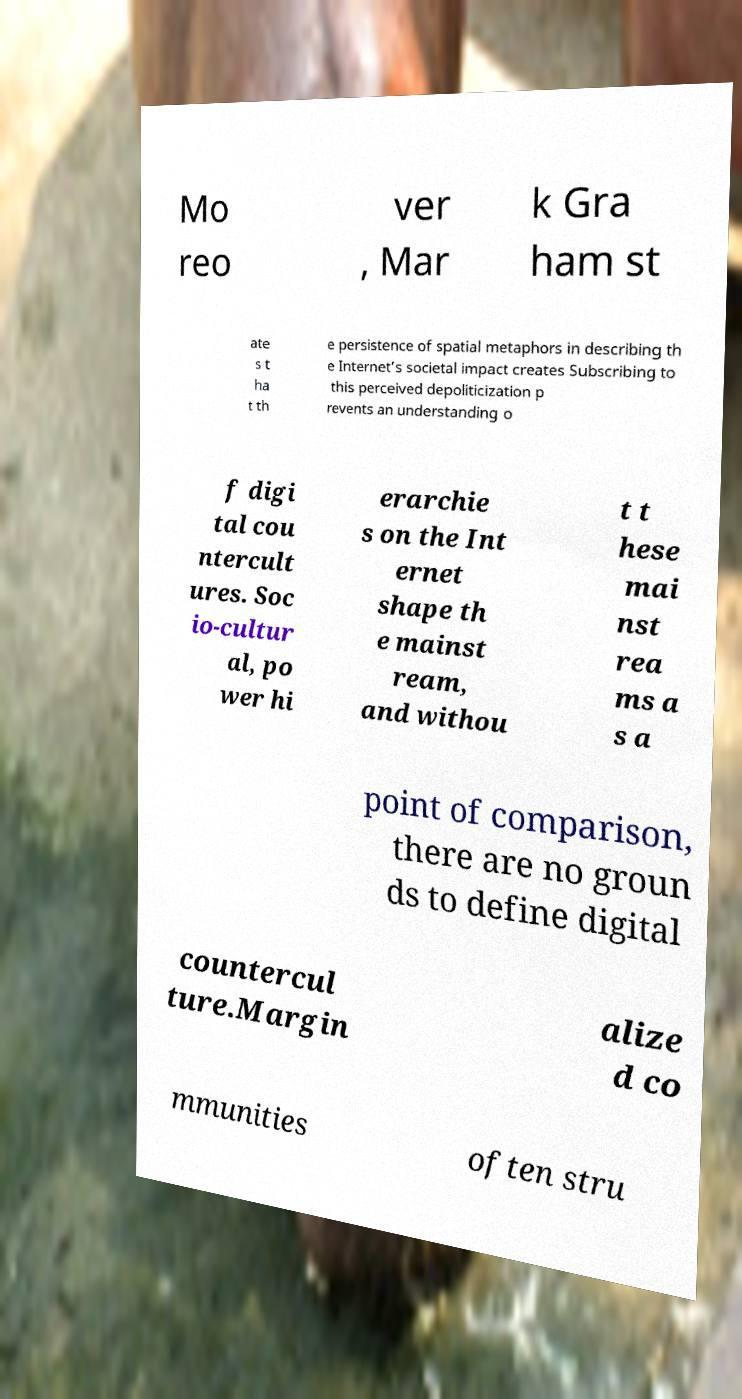Could you extract and type out the text from this image? Mo reo ver , Mar k Gra ham st ate s t ha t th e persistence of spatial metaphors in describing th e Internet’s societal impact creates Subscribing to this perceived depoliticization p revents an understanding o f digi tal cou ntercult ures. Soc io-cultur al, po wer hi erarchie s on the Int ernet shape th e mainst ream, and withou t t hese mai nst rea ms a s a point of comparison, there are no groun ds to define digital countercul ture.Margin alize d co mmunities often stru 